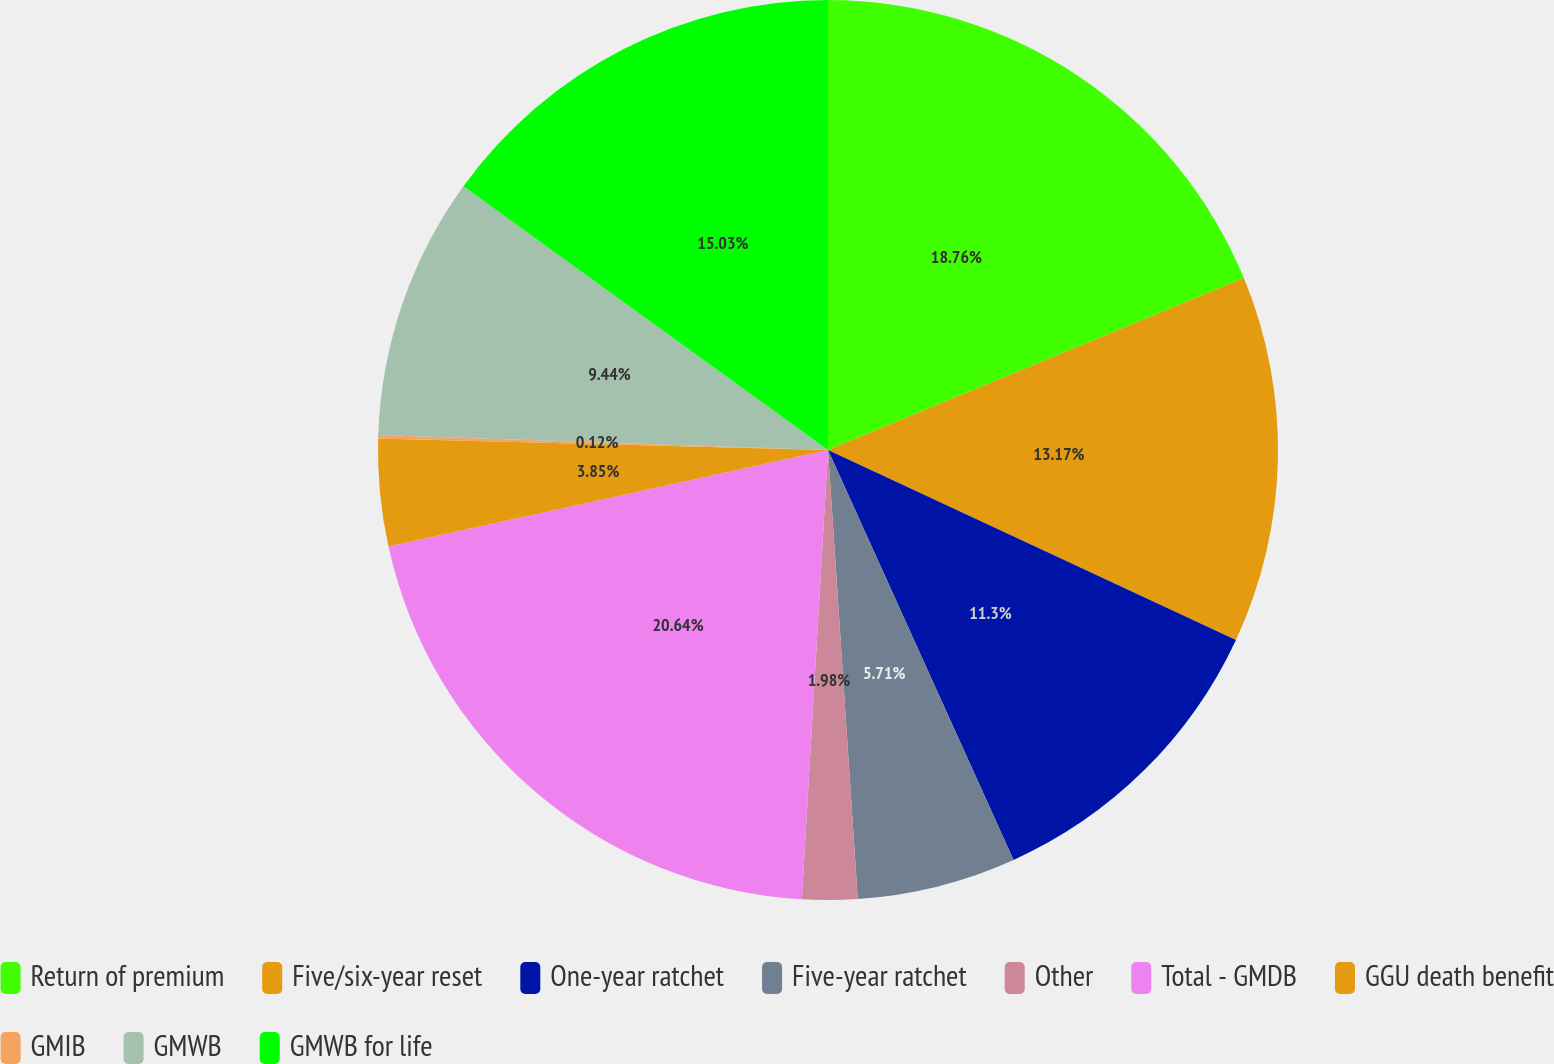<chart> <loc_0><loc_0><loc_500><loc_500><pie_chart><fcel>Return of premium<fcel>Five/six-year reset<fcel>One-year ratchet<fcel>Five-year ratchet<fcel>Other<fcel>Total - GMDB<fcel>GGU death benefit<fcel>GMIB<fcel>GMWB<fcel>GMWB for life<nl><fcel>18.76%<fcel>13.17%<fcel>11.3%<fcel>5.71%<fcel>1.98%<fcel>20.63%<fcel>3.85%<fcel>0.12%<fcel>9.44%<fcel>15.03%<nl></chart> 